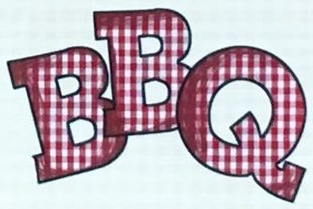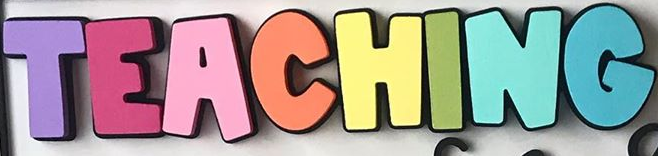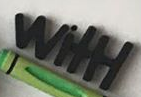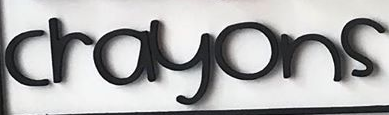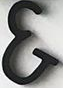What words are shown in these images in order, separated by a semicolon? BBQ; TEACHING; WitH; crayons; & 